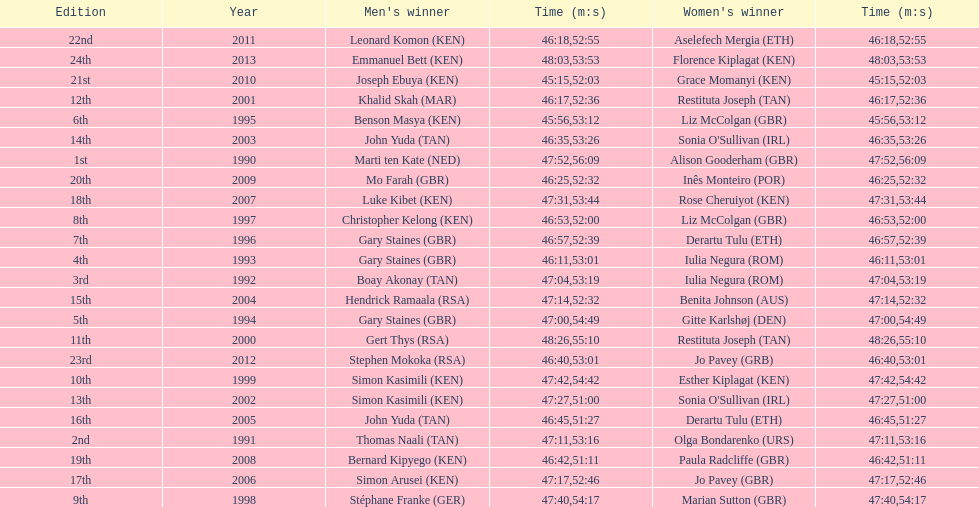What is the number of times, between 1990 and 2013, for britain not to win the men's or women's bupa great south run? 13. 